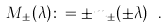Convert formula to latex. <formula><loc_0><loc_0><loc_500><loc_500>M _ { \pm } ( \lambda ) \colon = \pm m _ { \pm } ( \pm \lambda ) \ .</formula> 